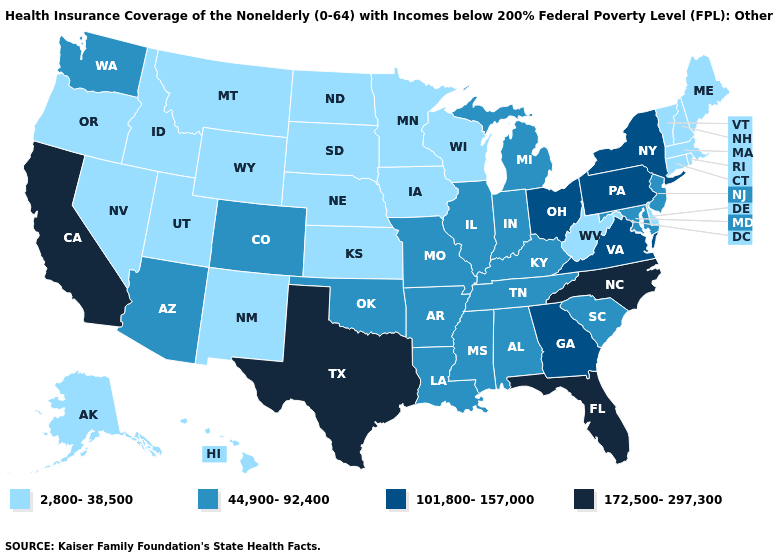Among the states that border New Jersey , does Delaware have the lowest value?
Answer briefly. Yes. What is the lowest value in the South?
Quick response, please. 2,800-38,500. Among the states that border Wisconsin , does Illinois have the highest value?
Short answer required. Yes. Does the map have missing data?
Be succinct. No. Name the states that have a value in the range 2,800-38,500?
Quick response, please. Alaska, Connecticut, Delaware, Hawaii, Idaho, Iowa, Kansas, Maine, Massachusetts, Minnesota, Montana, Nebraska, Nevada, New Hampshire, New Mexico, North Dakota, Oregon, Rhode Island, South Dakota, Utah, Vermont, West Virginia, Wisconsin, Wyoming. What is the value of North Carolina?
Be succinct. 172,500-297,300. What is the value of Oklahoma?
Short answer required. 44,900-92,400. Does Vermont have the lowest value in the Northeast?
Concise answer only. Yes. Which states have the lowest value in the USA?
Answer briefly. Alaska, Connecticut, Delaware, Hawaii, Idaho, Iowa, Kansas, Maine, Massachusetts, Minnesota, Montana, Nebraska, Nevada, New Hampshire, New Mexico, North Dakota, Oregon, Rhode Island, South Dakota, Utah, Vermont, West Virginia, Wisconsin, Wyoming. Does Wyoming have the same value as South Dakota?
Short answer required. Yes. Among the states that border New Jersey , which have the lowest value?
Give a very brief answer. Delaware. Does the map have missing data?
Quick response, please. No. Does Connecticut have a lower value than Maine?
Keep it brief. No. Does Minnesota have the highest value in the USA?
Keep it brief. No. Name the states that have a value in the range 172,500-297,300?
Be succinct. California, Florida, North Carolina, Texas. 